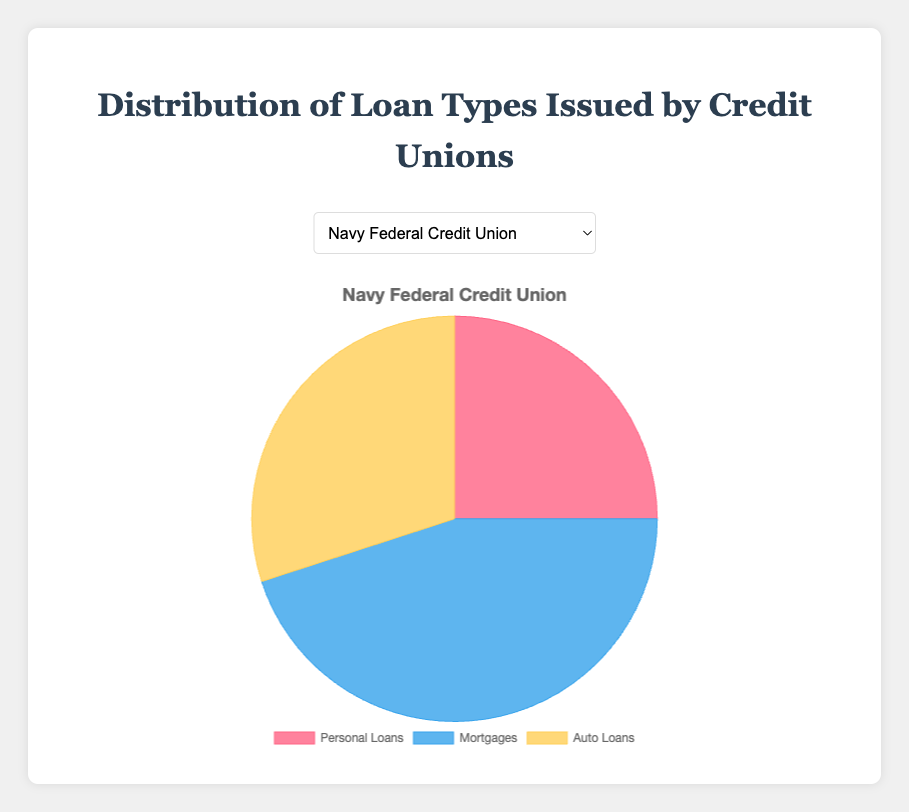Which credit union issues the highest percentage of mortgages? Looking at the pie charts, the Pentagon Federal Credit Union issues the highest percentage of mortgages at 50%.
Answer: Pentagon Federal Credit Union Compare the percentage of personal loans issued between Navy Federal Credit Union and State Employees' Credit Union. Navy Federal Credit Union issues 25% personal loans, while State Employees' Credit Union issues 35%. Therefore, State Employees' Credit Union issues 10% more personal loans than Navy Federal Credit Union.
Answer: State Employees' Credit Union issues more What is the total percentage of auto loans and personal loans issued by Boeing Employees Credit Union? The pie chart shows Boeing Employees Credit Union issues 30% auto loans and 28% personal loans. Adding these, 30% + 28% = 58%.
Answer: 58% Which type of loan is most commonly issued by SchoolsFirst Federal Credit Union? The SchoolsFirst Federal Credit Union pie chart shows that mortgages and auto loans are both the most common at 40% and 30%, respectively.
Answer: Mortgages and Auto Loans (30% each) How does the mortgage distribution of Navy Federal Credit Union compare to Boeing Employees Credit Union? The pie charts reveal that Navy Federal Credit Union issues 45% in mortgages, while Boeing Employees Credit Union issues 42% in mortgages. Thus, Navy Federal Credit Union has a slightly higher mortgage distribution by 3%.
Answer: Navy Federal Credit Union has a higher mortgage distribution Which credit union has the lowest percentage of personal loans? Reviewing the pie charts, Pentagon Federal Credit Union has the lowest percentage of personal loans at 20%.
Answer: Pentagon Federal Credit Union Find the sum of the percentages for personal loans and mortgages issued by the State Employees' Credit Union. The chart shows State Employees' Credit Union issues 35% personal loans and 40% mortgages. Summing them together, 35% + 40% = 75%.
Answer: 75% What percentage of loans is automatically issued as personal loans by Pentagon Federal Credit Union? According to the chart, Pentagon Federal Credit Union issues 20% of its loans as personal loans.
Answer: 20% 